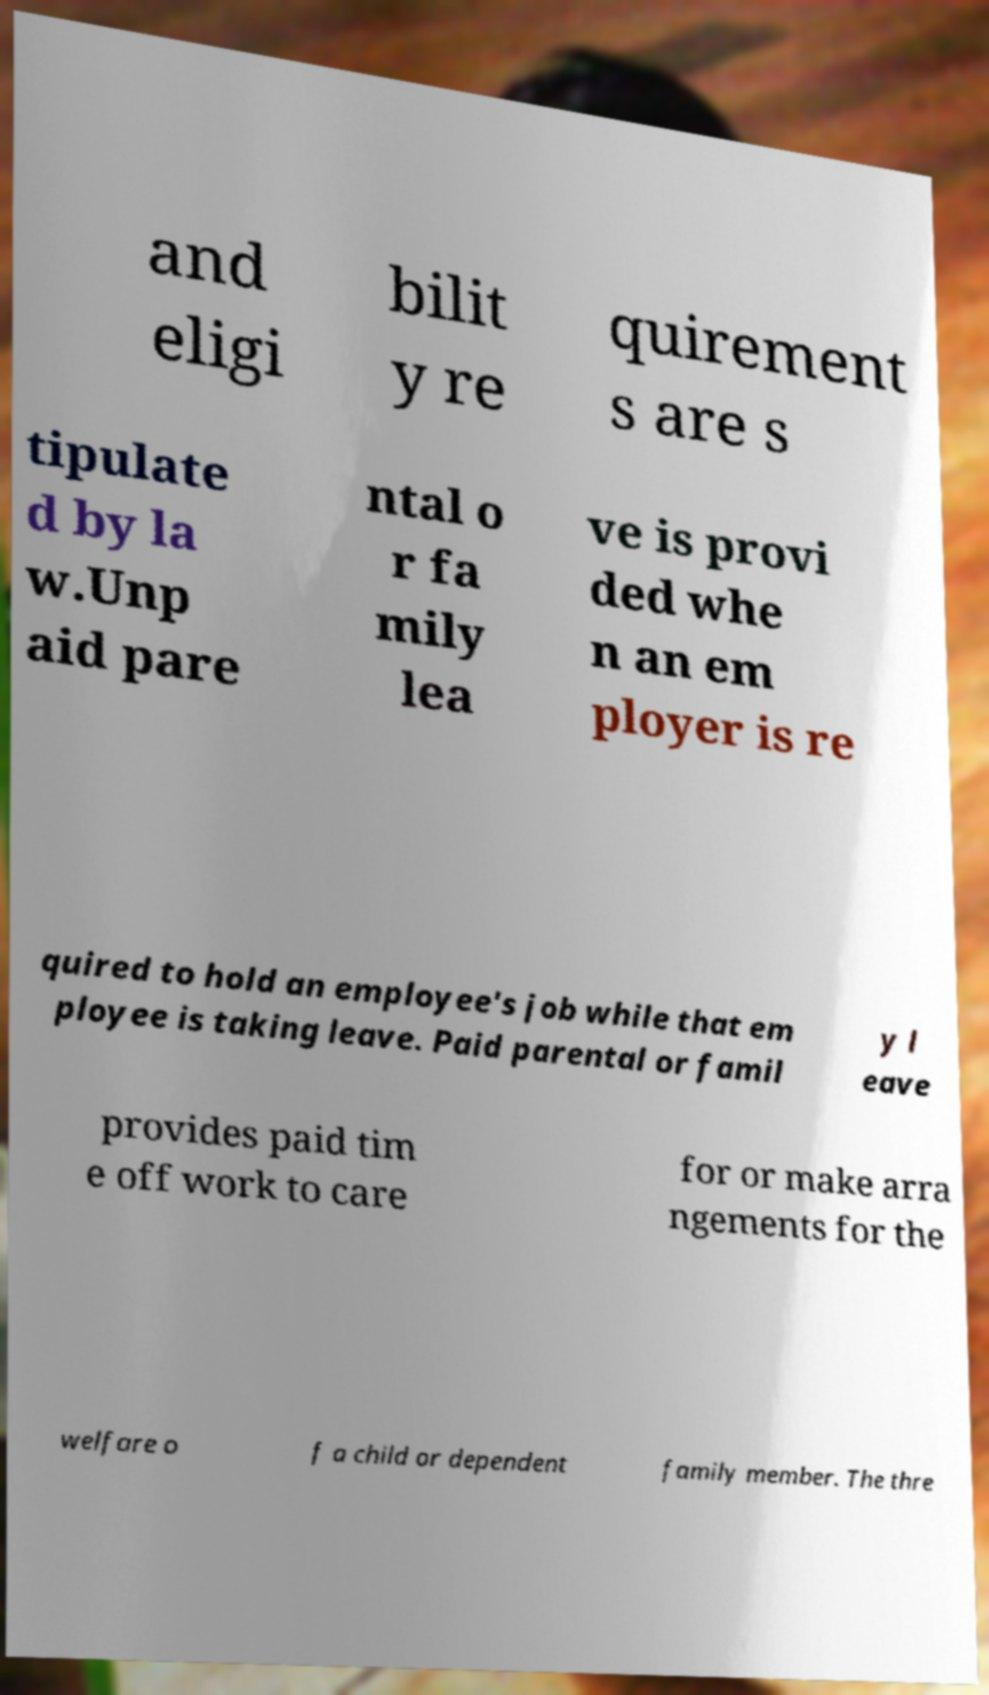What messages or text are displayed in this image? I need them in a readable, typed format. and eligi bilit y re quirement s are s tipulate d by la w.Unp aid pare ntal o r fa mily lea ve is provi ded whe n an em ployer is re quired to hold an employee's job while that em ployee is taking leave. Paid parental or famil y l eave provides paid tim e off work to care for or make arra ngements for the welfare o f a child or dependent family member. The thre 